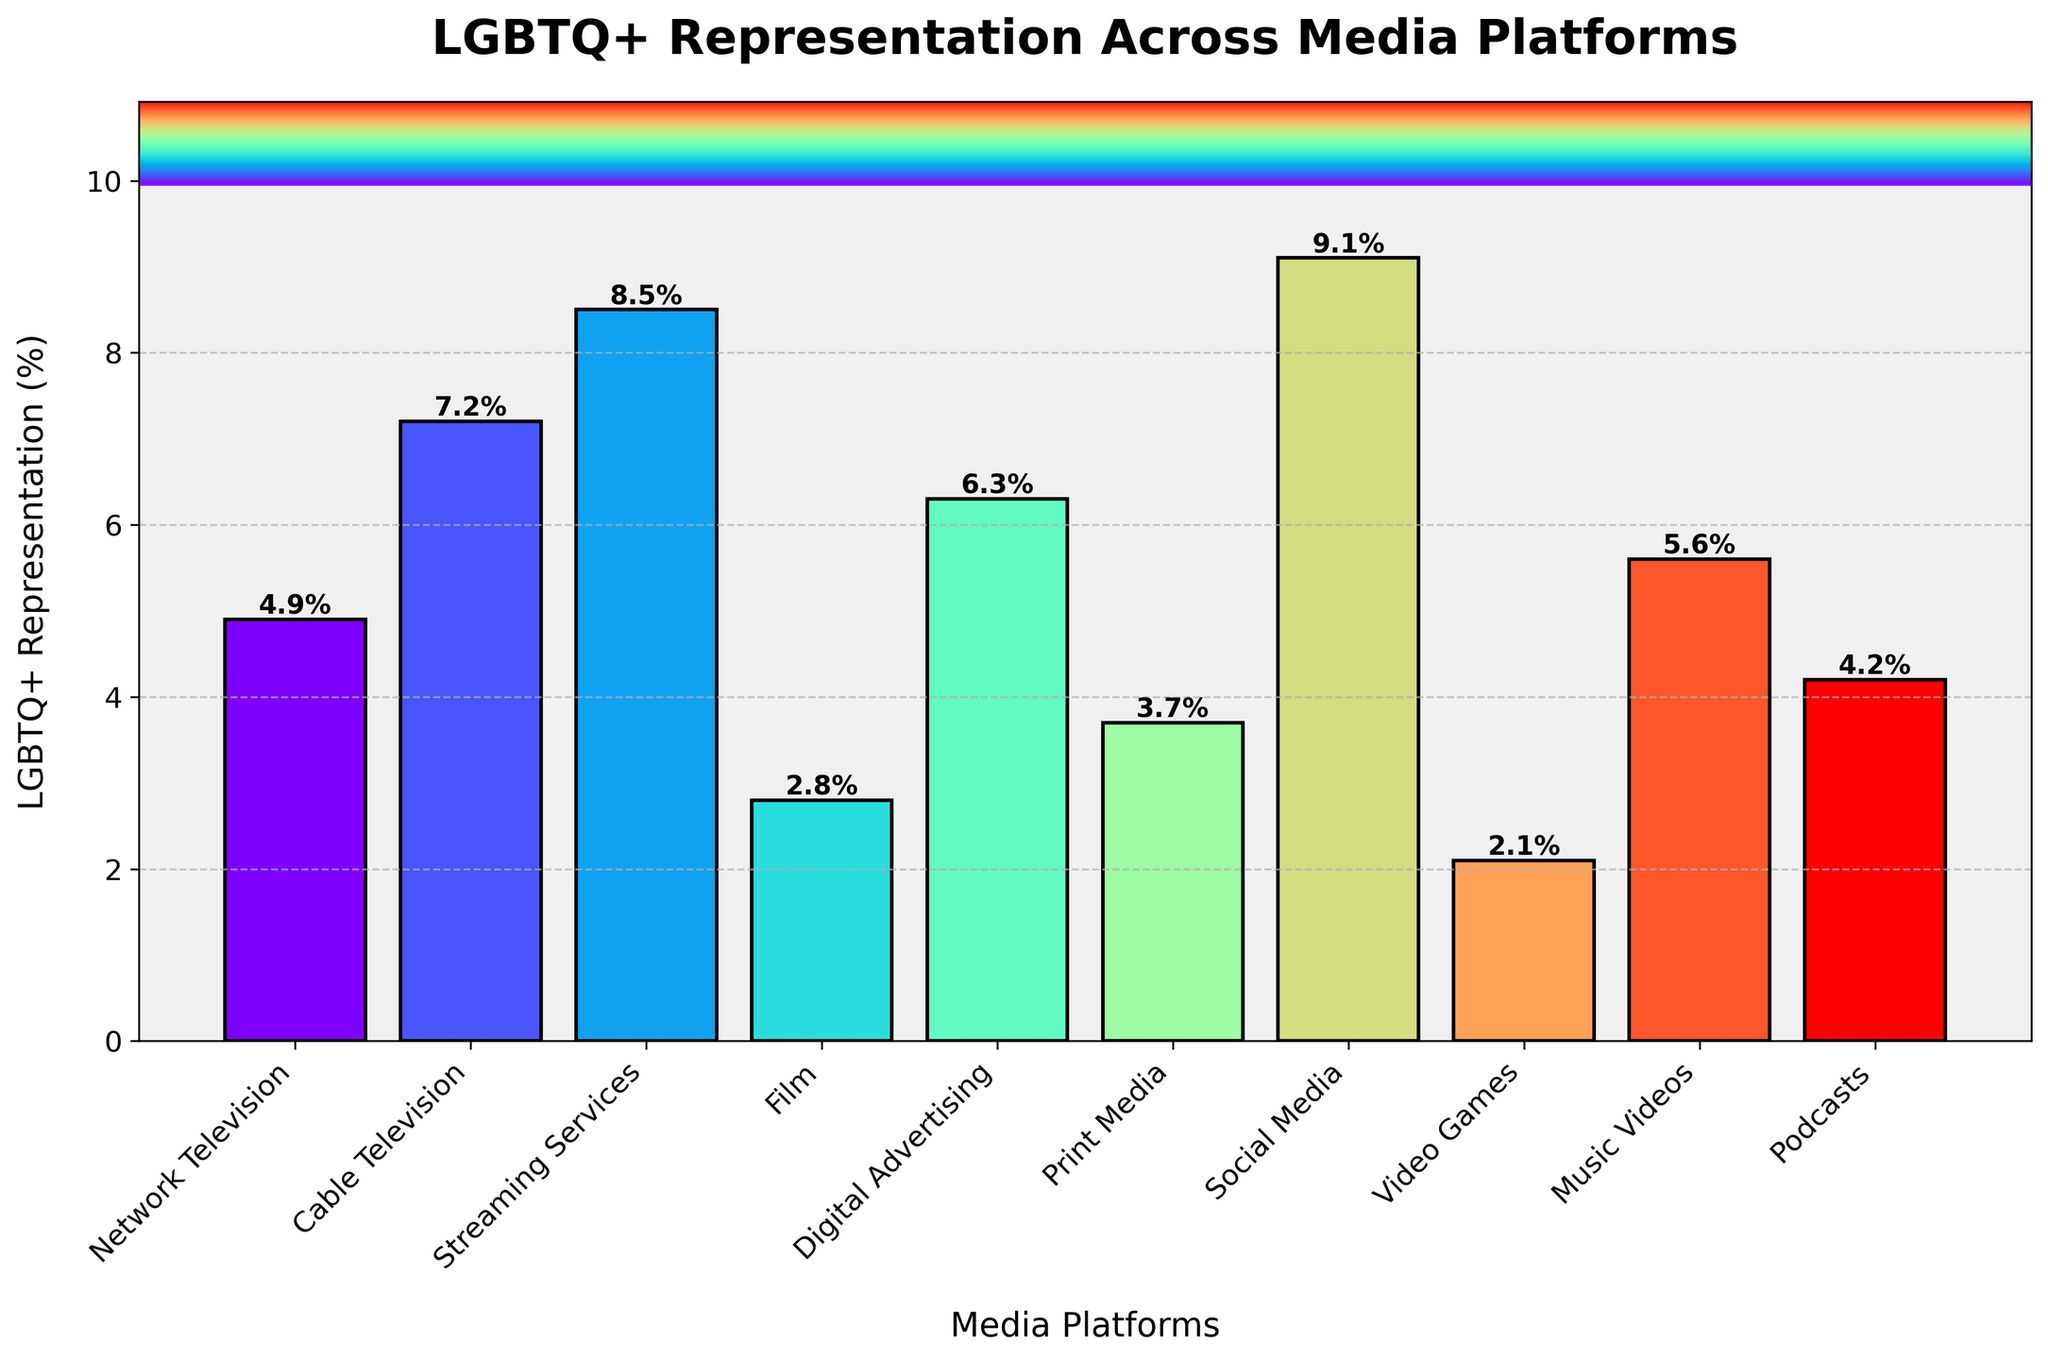What is the platform with the highest LGBTQ+ representation? Identify the column with the tallest bar. Social Media has the highest LGBTQ+ representation at 9.1%.
Answer: Social Media Which platform has more LGBTQ+ representation: Network Television or Podcasts? Compare the heights of the bars for Network Television and Podcasts, Network Television is at 4.9% and Podcasts are at 4.2%, so Network Television has more representation.
Answer: Network Television What is the difference in LGBTQ+ representation between Streaming Services and Film? Find the heights of the bars for Streaming Services (8.5%) and Film (2.8%), then subtract the smaller from the larger: 8.5% - 2.8% = 5.7%.
Answer: 5.7% Which platforms have an LGBTQ+ representation of over 7%? Identify the bars that are taller than 7%. Both Cable Television (7.2%), Streaming Services (8.5%), and Social Media (9.1%) have LGBTQ+ representation over 7%.
Answer: Cable Television, Streaming Services, Social Media Is the LGBTQ+ representation in Print Media greater than or equal to Video Games? Compare the heights of the bars for Print Media and Video Games. Print Media is at 3.7%, and Video Games is at 2.1%, so Print Media is greater than Video Games.
Answer: Yes What is the average LGBTQ+ representation across all platforms? Add up all the percentages and divide by the number of platforms: (4.9 + 7.2 + 8.5 + 2.8 + 6.3 + 3.7 + 9.1 + 2.1 + 5.6 + 4.2) / 10 = 5.44%.
Answer: 5.44% Which two platforms combined have exactly 11.2% representation? Look for a combination of two platforms where their representations add up to 11.2%. Network Television (4.9%) and Music Videos (5.6%) together add up to 11.2%.
Answer: Network Television and Music Videos What is the lowest LGBTQ+ representation percentage, and which platform does it belong to? Identify the column with the shortest bar. Video Games have the lowest representation at 2.1%.
Answer: 2.1%, Video Games What is the total LGBTQ+ representation percentage for all forms of Television (Network, Cable, and Streaming)? Add the percentages of Network Television, Cable Television, and Streaming Services: 4.9% + 7.2% + 8.5% = 20.6%.
Answer: 20.6% 